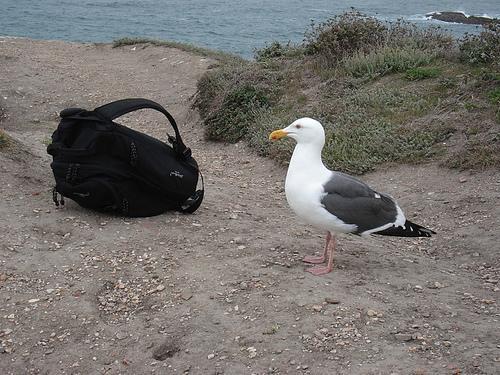How many birds are shown?
Give a very brief answer. 1. How many people in the air are there?
Give a very brief answer. 0. 